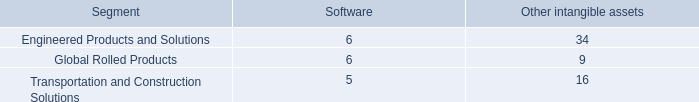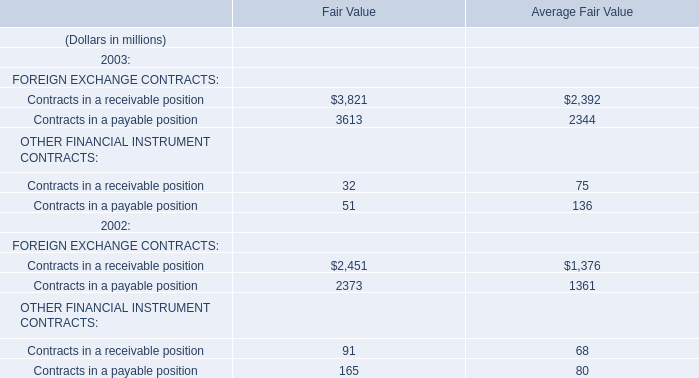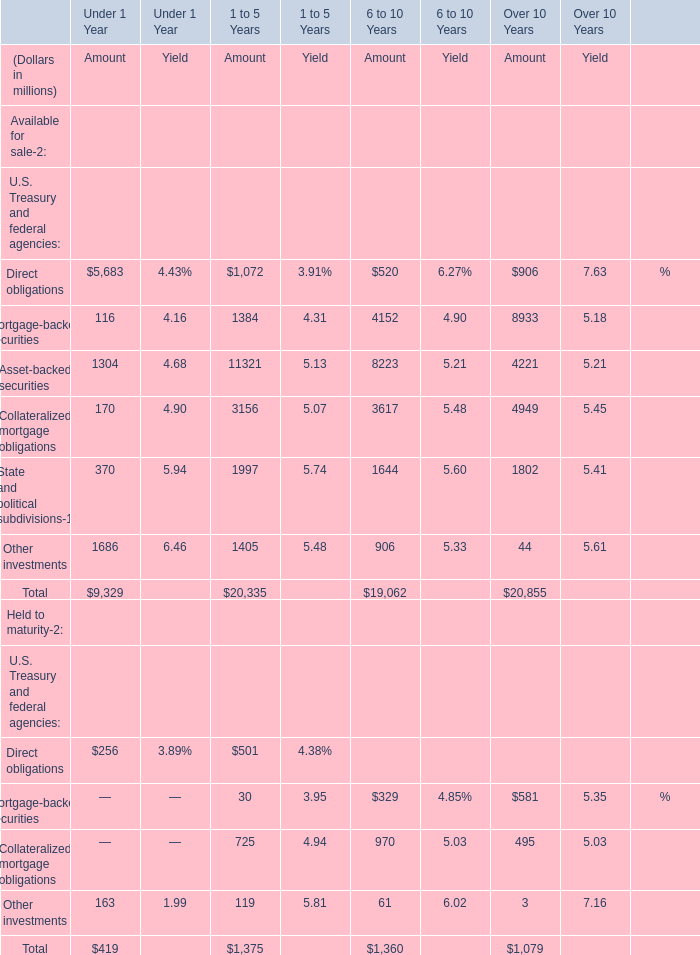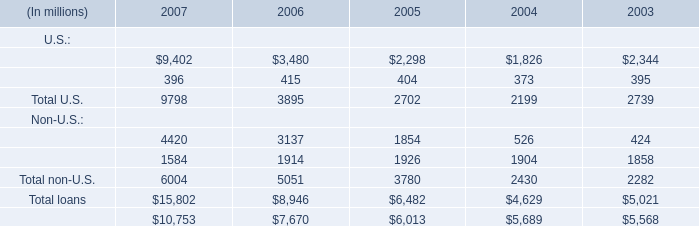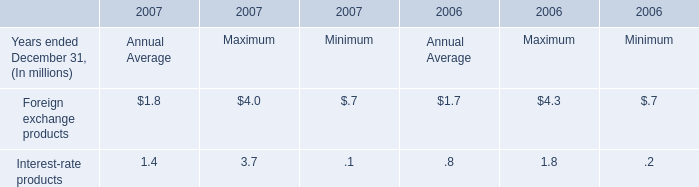If Commercial and financial for U.S. develops with the same growth rate in 2007, what will it reach in 2008? (in million) 
Computations: (9402 * (1 + ((9402 - 3480) / 3480)))
Answer: 25401.61034. 